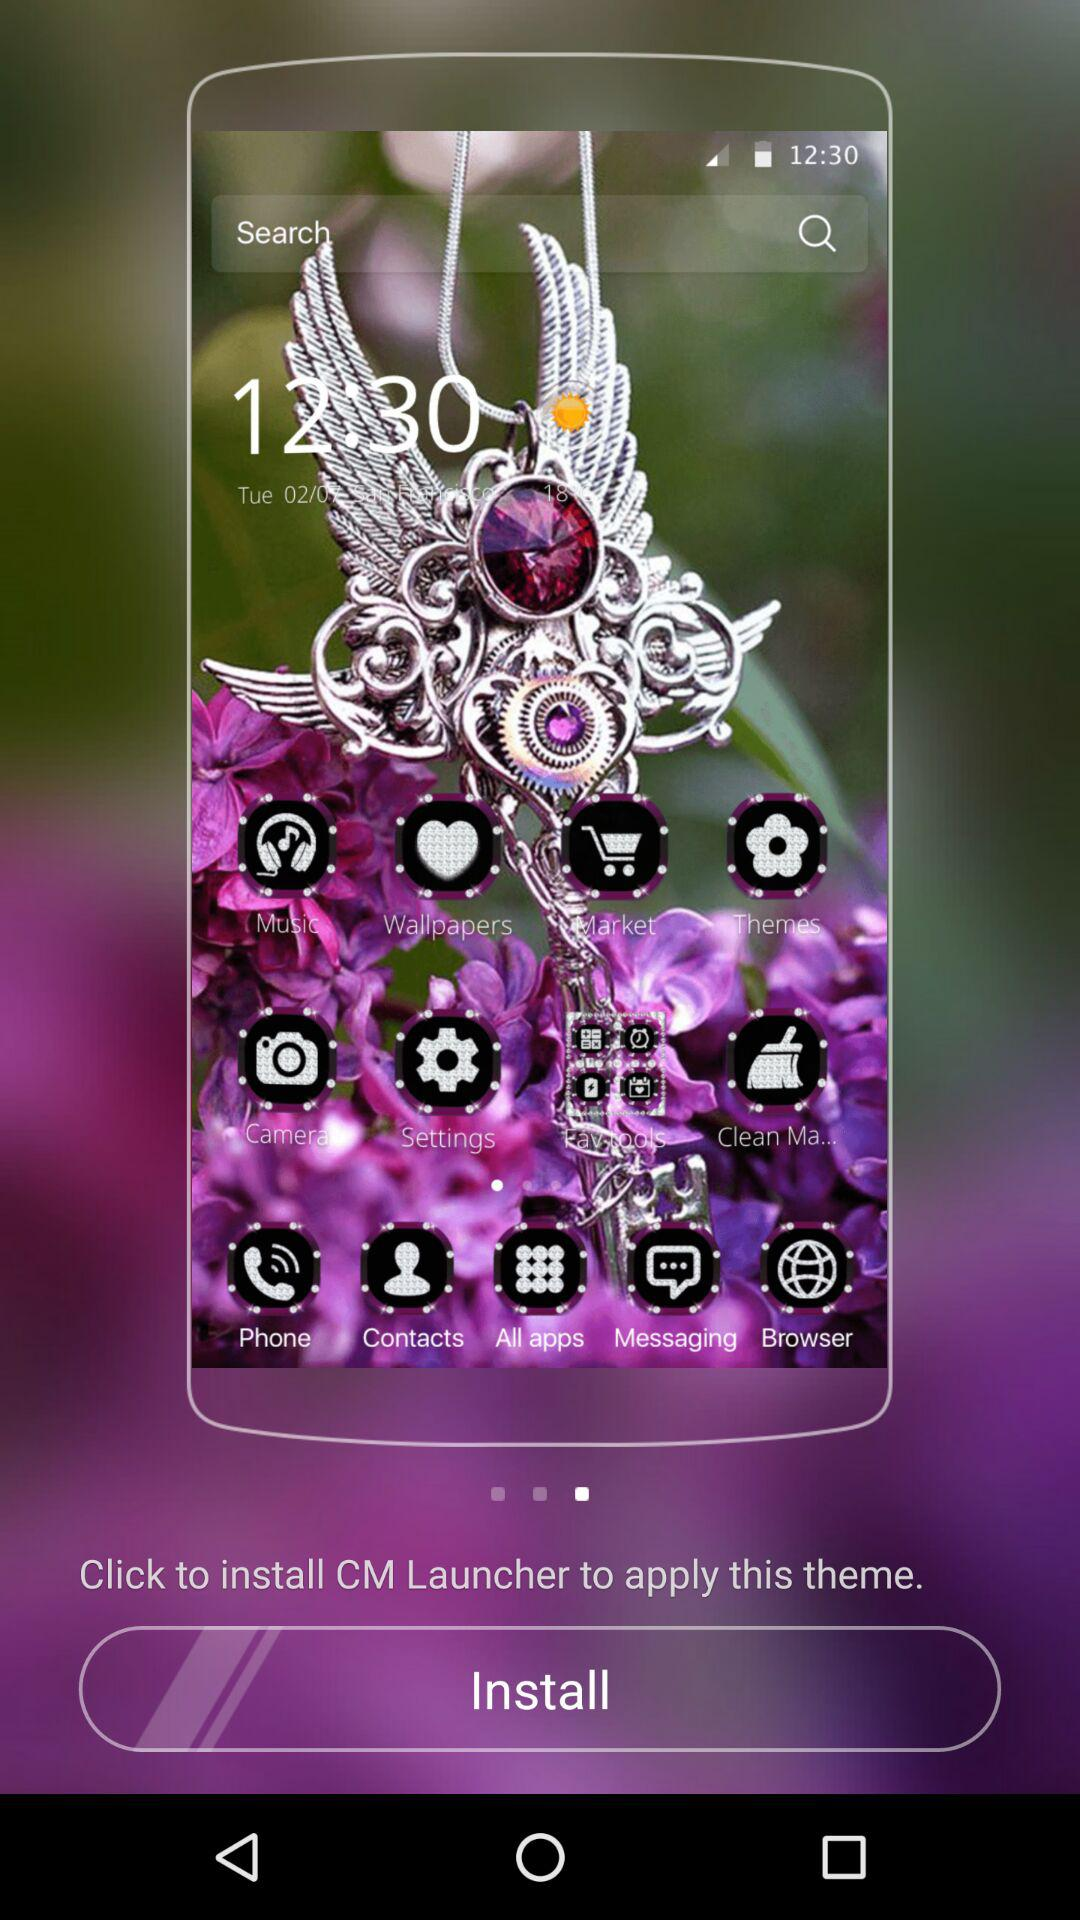What is the name of the application? The name of the application is "CM Launcher". 